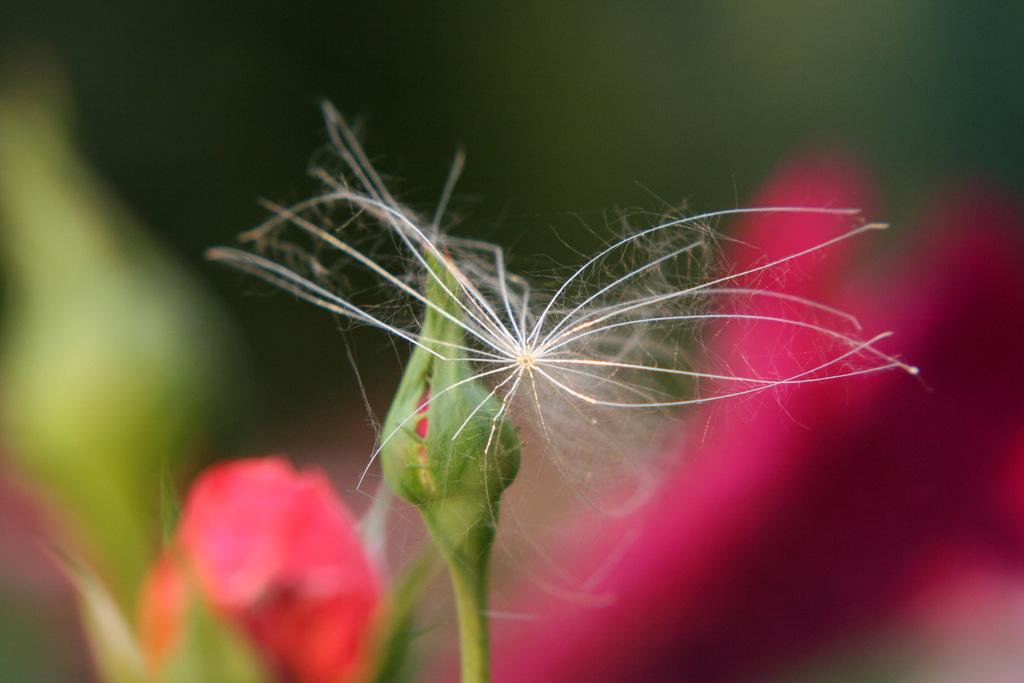What type of living organisms can be seen in the image? There are flowers and an insect in the image. Can you describe the stage of the flower in the image? There is a bud in the image. What is the insect doing in the image? The insect is present on the bud. How would you describe the background of the image? The background of the image is blurred. What advice does the father give to the flowers in the image? There is no father present in the image, so it is not possible to answer that question. 